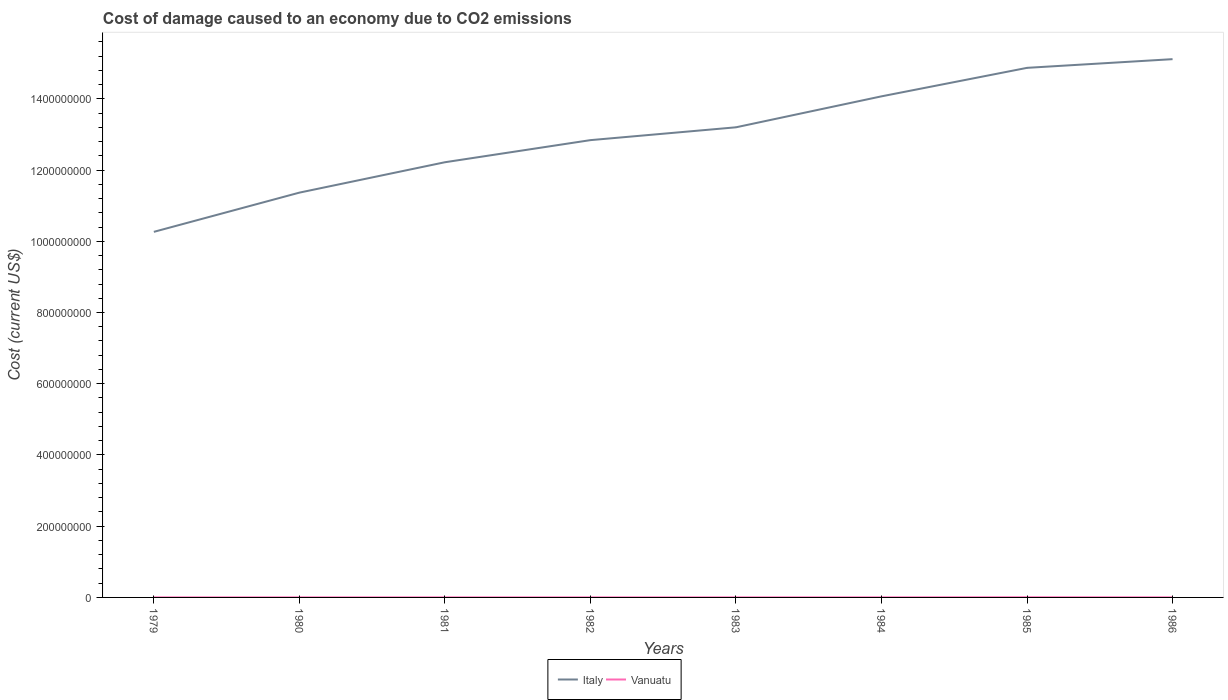Does the line corresponding to Italy intersect with the line corresponding to Vanuatu?
Provide a succinct answer. No. Is the number of lines equal to the number of legend labels?
Ensure brevity in your answer.  Yes. Across all years, what is the maximum cost of damage caused due to CO2 emissisons in Vanuatu?
Ensure brevity in your answer.  1.65e+05. In which year was the cost of damage caused due to CO2 emissisons in Italy maximum?
Your answer should be compact. 1979. What is the total cost of damage caused due to CO2 emissisons in Italy in the graph?
Keep it short and to the point. -3.60e+07. What is the difference between the highest and the second highest cost of damage caused due to CO2 emissisons in Vanuatu?
Make the answer very short. 3.18e+05. What is the difference between the highest and the lowest cost of damage caused due to CO2 emissisons in Vanuatu?
Offer a very short reply. 2. How many years are there in the graph?
Ensure brevity in your answer.  8. Where does the legend appear in the graph?
Offer a very short reply. Bottom center. How are the legend labels stacked?
Give a very brief answer. Horizontal. What is the title of the graph?
Your answer should be compact. Cost of damage caused to an economy due to CO2 emissions. What is the label or title of the X-axis?
Your response must be concise. Years. What is the label or title of the Y-axis?
Offer a very short reply. Cost (current US$). What is the Cost (current US$) in Italy in 1979?
Give a very brief answer. 1.03e+09. What is the Cost (current US$) of Vanuatu in 1979?
Your response must be concise. 1.65e+05. What is the Cost (current US$) in Italy in 1980?
Provide a short and direct response. 1.14e+09. What is the Cost (current US$) in Vanuatu in 1980?
Your answer should be compact. 1.82e+05. What is the Cost (current US$) in Italy in 1981?
Your answer should be compact. 1.22e+09. What is the Cost (current US$) of Vanuatu in 1981?
Keep it short and to the point. 1.66e+05. What is the Cost (current US$) of Italy in 1982?
Provide a short and direct response. 1.28e+09. What is the Cost (current US$) in Vanuatu in 1982?
Give a very brief answer. 1.78e+05. What is the Cost (current US$) of Italy in 1983?
Ensure brevity in your answer.  1.32e+09. What is the Cost (current US$) in Vanuatu in 1983?
Your response must be concise. 2.01e+05. What is the Cost (current US$) in Italy in 1984?
Give a very brief answer. 1.41e+09. What is the Cost (current US$) of Vanuatu in 1984?
Your answer should be very brief. 2.10e+05. What is the Cost (current US$) in Italy in 1985?
Your response must be concise. 1.49e+09. What is the Cost (current US$) of Vanuatu in 1985?
Provide a succinct answer. 4.84e+05. What is the Cost (current US$) in Italy in 1986?
Make the answer very short. 1.51e+09. What is the Cost (current US$) in Vanuatu in 1986?
Provide a succinct answer. 2.42e+05. Across all years, what is the maximum Cost (current US$) of Italy?
Your answer should be very brief. 1.51e+09. Across all years, what is the maximum Cost (current US$) in Vanuatu?
Give a very brief answer. 4.84e+05. Across all years, what is the minimum Cost (current US$) in Italy?
Make the answer very short. 1.03e+09. Across all years, what is the minimum Cost (current US$) in Vanuatu?
Offer a terse response. 1.65e+05. What is the total Cost (current US$) of Italy in the graph?
Keep it short and to the point. 1.04e+1. What is the total Cost (current US$) in Vanuatu in the graph?
Your answer should be compact. 1.83e+06. What is the difference between the Cost (current US$) of Italy in 1979 and that in 1980?
Provide a succinct answer. -1.10e+08. What is the difference between the Cost (current US$) in Vanuatu in 1979 and that in 1980?
Give a very brief answer. -1.70e+04. What is the difference between the Cost (current US$) of Italy in 1979 and that in 1981?
Offer a very short reply. -1.95e+08. What is the difference between the Cost (current US$) in Vanuatu in 1979 and that in 1981?
Ensure brevity in your answer.  -796.84. What is the difference between the Cost (current US$) of Italy in 1979 and that in 1982?
Keep it short and to the point. -2.58e+08. What is the difference between the Cost (current US$) in Vanuatu in 1979 and that in 1982?
Give a very brief answer. -1.32e+04. What is the difference between the Cost (current US$) in Italy in 1979 and that in 1983?
Keep it short and to the point. -2.94e+08. What is the difference between the Cost (current US$) of Vanuatu in 1979 and that in 1983?
Your answer should be compact. -3.58e+04. What is the difference between the Cost (current US$) of Italy in 1979 and that in 1984?
Ensure brevity in your answer.  -3.80e+08. What is the difference between the Cost (current US$) of Vanuatu in 1979 and that in 1984?
Make the answer very short. -4.53e+04. What is the difference between the Cost (current US$) of Italy in 1979 and that in 1985?
Your answer should be very brief. -4.60e+08. What is the difference between the Cost (current US$) in Vanuatu in 1979 and that in 1985?
Provide a succinct answer. -3.18e+05. What is the difference between the Cost (current US$) in Italy in 1979 and that in 1986?
Provide a succinct answer. -4.85e+08. What is the difference between the Cost (current US$) in Vanuatu in 1979 and that in 1986?
Provide a short and direct response. -7.68e+04. What is the difference between the Cost (current US$) in Italy in 1980 and that in 1981?
Provide a short and direct response. -8.53e+07. What is the difference between the Cost (current US$) in Vanuatu in 1980 and that in 1981?
Offer a terse response. 1.62e+04. What is the difference between the Cost (current US$) of Italy in 1980 and that in 1982?
Your response must be concise. -1.47e+08. What is the difference between the Cost (current US$) in Vanuatu in 1980 and that in 1982?
Ensure brevity in your answer.  3847.55. What is the difference between the Cost (current US$) of Italy in 1980 and that in 1983?
Your response must be concise. -1.83e+08. What is the difference between the Cost (current US$) of Vanuatu in 1980 and that in 1983?
Ensure brevity in your answer.  -1.88e+04. What is the difference between the Cost (current US$) in Italy in 1980 and that in 1984?
Provide a succinct answer. -2.70e+08. What is the difference between the Cost (current US$) of Vanuatu in 1980 and that in 1984?
Ensure brevity in your answer.  -2.83e+04. What is the difference between the Cost (current US$) in Italy in 1980 and that in 1985?
Provide a succinct answer. -3.50e+08. What is the difference between the Cost (current US$) in Vanuatu in 1980 and that in 1985?
Make the answer very short. -3.01e+05. What is the difference between the Cost (current US$) of Italy in 1980 and that in 1986?
Give a very brief answer. -3.75e+08. What is the difference between the Cost (current US$) of Vanuatu in 1980 and that in 1986?
Your answer should be compact. -5.98e+04. What is the difference between the Cost (current US$) of Italy in 1981 and that in 1982?
Give a very brief answer. -6.21e+07. What is the difference between the Cost (current US$) in Vanuatu in 1981 and that in 1982?
Make the answer very short. -1.24e+04. What is the difference between the Cost (current US$) in Italy in 1981 and that in 1983?
Offer a very short reply. -9.81e+07. What is the difference between the Cost (current US$) in Vanuatu in 1981 and that in 1983?
Your answer should be very brief. -3.50e+04. What is the difference between the Cost (current US$) in Italy in 1981 and that in 1984?
Keep it short and to the point. -1.85e+08. What is the difference between the Cost (current US$) of Vanuatu in 1981 and that in 1984?
Keep it short and to the point. -4.46e+04. What is the difference between the Cost (current US$) in Italy in 1981 and that in 1985?
Ensure brevity in your answer.  -2.65e+08. What is the difference between the Cost (current US$) in Vanuatu in 1981 and that in 1985?
Give a very brief answer. -3.18e+05. What is the difference between the Cost (current US$) of Italy in 1981 and that in 1986?
Offer a very short reply. -2.89e+08. What is the difference between the Cost (current US$) in Vanuatu in 1981 and that in 1986?
Offer a very short reply. -7.60e+04. What is the difference between the Cost (current US$) in Italy in 1982 and that in 1983?
Make the answer very short. -3.60e+07. What is the difference between the Cost (current US$) of Vanuatu in 1982 and that in 1983?
Offer a very short reply. -2.26e+04. What is the difference between the Cost (current US$) in Italy in 1982 and that in 1984?
Keep it short and to the point. -1.23e+08. What is the difference between the Cost (current US$) in Vanuatu in 1982 and that in 1984?
Offer a very short reply. -3.22e+04. What is the difference between the Cost (current US$) in Italy in 1982 and that in 1985?
Your response must be concise. -2.03e+08. What is the difference between the Cost (current US$) of Vanuatu in 1982 and that in 1985?
Give a very brief answer. -3.05e+05. What is the difference between the Cost (current US$) in Italy in 1982 and that in 1986?
Your response must be concise. -2.27e+08. What is the difference between the Cost (current US$) in Vanuatu in 1982 and that in 1986?
Your response must be concise. -6.37e+04. What is the difference between the Cost (current US$) in Italy in 1983 and that in 1984?
Offer a terse response. -8.69e+07. What is the difference between the Cost (current US$) in Vanuatu in 1983 and that in 1984?
Your answer should be compact. -9573.04. What is the difference between the Cost (current US$) of Italy in 1983 and that in 1985?
Offer a terse response. -1.67e+08. What is the difference between the Cost (current US$) in Vanuatu in 1983 and that in 1985?
Offer a very short reply. -2.83e+05. What is the difference between the Cost (current US$) in Italy in 1983 and that in 1986?
Your answer should be very brief. -1.91e+08. What is the difference between the Cost (current US$) in Vanuatu in 1983 and that in 1986?
Offer a terse response. -4.11e+04. What is the difference between the Cost (current US$) of Italy in 1984 and that in 1985?
Your response must be concise. -8.00e+07. What is the difference between the Cost (current US$) in Vanuatu in 1984 and that in 1985?
Make the answer very short. -2.73e+05. What is the difference between the Cost (current US$) in Italy in 1984 and that in 1986?
Ensure brevity in your answer.  -1.04e+08. What is the difference between the Cost (current US$) in Vanuatu in 1984 and that in 1986?
Keep it short and to the point. -3.15e+04. What is the difference between the Cost (current US$) in Italy in 1985 and that in 1986?
Give a very brief answer. -2.44e+07. What is the difference between the Cost (current US$) of Vanuatu in 1985 and that in 1986?
Offer a very short reply. 2.42e+05. What is the difference between the Cost (current US$) in Italy in 1979 and the Cost (current US$) in Vanuatu in 1980?
Give a very brief answer. 1.03e+09. What is the difference between the Cost (current US$) of Italy in 1979 and the Cost (current US$) of Vanuatu in 1981?
Your answer should be very brief. 1.03e+09. What is the difference between the Cost (current US$) in Italy in 1979 and the Cost (current US$) in Vanuatu in 1982?
Make the answer very short. 1.03e+09. What is the difference between the Cost (current US$) of Italy in 1979 and the Cost (current US$) of Vanuatu in 1983?
Provide a short and direct response. 1.03e+09. What is the difference between the Cost (current US$) in Italy in 1979 and the Cost (current US$) in Vanuatu in 1984?
Keep it short and to the point. 1.03e+09. What is the difference between the Cost (current US$) in Italy in 1979 and the Cost (current US$) in Vanuatu in 1985?
Make the answer very short. 1.03e+09. What is the difference between the Cost (current US$) in Italy in 1979 and the Cost (current US$) in Vanuatu in 1986?
Keep it short and to the point. 1.03e+09. What is the difference between the Cost (current US$) in Italy in 1980 and the Cost (current US$) in Vanuatu in 1981?
Ensure brevity in your answer.  1.14e+09. What is the difference between the Cost (current US$) of Italy in 1980 and the Cost (current US$) of Vanuatu in 1982?
Offer a very short reply. 1.14e+09. What is the difference between the Cost (current US$) of Italy in 1980 and the Cost (current US$) of Vanuatu in 1983?
Provide a short and direct response. 1.14e+09. What is the difference between the Cost (current US$) in Italy in 1980 and the Cost (current US$) in Vanuatu in 1984?
Provide a short and direct response. 1.14e+09. What is the difference between the Cost (current US$) in Italy in 1980 and the Cost (current US$) in Vanuatu in 1985?
Offer a very short reply. 1.14e+09. What is the difference between the Cost (current US$) of Italy in 1980 and the Cost (current US$) of Vanuatu in 1986?
Offer a terse response. 1.14e+09. What is the difference between the Cost (current US$) in Italy in 1981 and the Cost (current US$) in Vanuatu in 1982?
Offer a terse response. 1.22e+09. What is the difference between the Cost (current US$) in Italy in 1981 and the Cost (current US$) in Vanuatu in 1983?
Your response must be concise. 1.22e+09. What is the difference between the Cost (current US$) of Italy in 1981 and the Cost (current US$) of Vanuatu in 1984?
Offer a terse response. 1.22e+09. What is the difference between the Cost (current US$) in Italy in 1981 and the Cost (current US$) in Vanuatu in 1985?
Provide a short and direct response. 1.22e+09. What is the difference between the Cost (current US$) in Italy in 1981 and the Cost (current US$) in Vanuatu in 1986?
Provide a succinct answer. 1.22e+09. What is the difference between the Cost (current US$) in Italy in 1982 and the Cost (current US$) in Vanuatu in 1983?
Make the answer very short. 1.28e+09. What is the difference between the Cost (current US$) of Italy in 1982 and the Cost (current US$) of Vanuatu in 1984?
Provide a succinct answer. 1.28e+09. What is the difference between the Cost (current US$) in Italy in 1982 and the Cost (current US$) in Vanuatu in 1985?
Offer a very short reply. 1.28e+09. What is the difference between the Cost (current US$) of Italy in 1982 and the Cost (current US$) of Vanuatu in 1986?
Keep it short and to the point. 1.28e+09. What is the difference between the Cost (current US$) in Italy in 1983 and the Cost (current US$) in Vanuatu in 1984?
Provide a succinct answer. 1.32e+09. What is the difference between the Cost (current US$) of Italy in 1983 and the Cost (current US$) of Vanuatu in 1985?
Your answer should be compact. 1.32e+09. What is the difference between the Cost (current US$) in Italy in 1983 and the Cost (current US$) in Vanuatu in 1986?
Ensure brevity in your answer.  1.32e+09. What is the difference between the Cost (current US$) of Italy in 1984 and the Cost (current US$) of Vanuatu in 1985?
Your response must be concise. 1.41e+09. What is the difference between the Cost (current US$) in Italy in 1984 and the Cost (current US$) in Vanuatu in 1986?
Offer a terse response. 1.41e+09. What is the difference between the Cost (current US$) in Italy in 1985 and the Cost (current US$) in Vanuatu in 1986?
Offer a terse response. 1.49e+09. What is the average Cost (current US$) in Italy per year?
Provide a succinct answer. 1.30e+09. What is the average Cost (current US$) in Vanuatu per year?
Your response must be concise. 2.29e+05. In the year 1979, what is the difference between the Cost (current US$) of Italy and Cost (current US$) of Vanuatu?
Offer a very short reply. 1.03e+09. In the year 1980, what is the difference between the Cost (current US$) in Italy and Cost (current US$) in Vanuatu?
Ensure brevity in your answer.  1.14e+09. In the year 1981, what is the difference between the Cost (current US$) of Italy and Cost (current US$) of Vanuatu?
Provide a short and direct response. 1.22e+09. In the year 1982, what is the difference between the Cost (current US$) of Italy and Cost (current US$) of Vanuatu?
Provide a short and direct response. 1.28e+09. In the year 1983, what is the difference between the Cost (current US$) in Italy and Cost (current US$) in Vanuatu?
Provide a short and direct response. 1.32e+09. In the year 1984, what is the difference between the Cost (current US$) of Italy and Cost (current US$) of Vanuatu?
Keep it short and to the point. 1.41e+09. In the year 1985, what is the difference between the Cost (current US$) of Italy and Cost (current US$) of Vanuatu?
Make the answer very short. 1.49e+09. In the year 1986, what is the difference between the Cost (current US$) in Italy and Cost (current US$) in Vanuatu?
Offer a terse response. 1.51e+09. What is the ratio of the Cost (current US$) in Italy in 1979 to that in 1980?
Your answer should be compact. 0.9. What is the ratio of the Cost (current US$) of Vanuatu in 1979 to that in 1980?
Your response must be concise. 0.91. What is the ratio of the Cost (current US$) in Italy in 1979 to that in 1981?
Ensure brevity in your answer.  0.84. What is the ratio of the Cost (current US$) of Vanuatu in 1979 to that in 1981?
Keep it short and to the point. 1. What is the ratio of the Cost (current US$) in Italy in 1979 to that in 1982?
Your answer should be very brief. 0.8. What is the ratio of the Cost (current US$) in Vanuatu in 1979 to that in 1982?
Provide a succinct answer. 0.93. What is the ratio of the Cost (current US$) of Italy in 1979 to that in 1983?
Your answer should be very brief. 0.78. What is the ratio of the Cost (current US$) in Vanuatu in 1979 to that in 1983?
Make the answer very short. 0.82. What is the ratio of the Cost (current US$) of Italy in 1979 to that in 1984?
Your answer should be very brief. 0.73. What is the ratio of the Cost (current US$) of Vanuatu in 1979 to that in 1984?
Your answer should be compact. 0.78. What is the ratio of the Cost (current US$) of Italy in 1979 to that in 1985?
Offer a very short reply. 0.69. What is the ratio of the Cost (current US$) in Vanuatu in 1979 to that in 1985?
Give a very brief answer. 0.34. What is the ratio of the Cost (current US$) in Italy in 1979 to that in 1986?
Offer a very short reply. 0.68. What is the ratio of the Cost (current US$) in Vanuatu in 1979 to that in 1986?
Make the answer very short. 0.68. What is the ratio of the Cost (current US$) of Italy in 1980 to that in 1981?
Keep it short and to the point. 0.93. What is the ratio of the Cost (current US$) of Vanuatu in 1980 to that in 1981?
Provide a succinct answer. 1.1. What is the ratio of the Cost (current US$) of Italy in 1980 to that in 1982?
Make the answer very short. 0.89. What is the ratio of the Cost (current US$) in Vanuatu in 1980 to that in 1982?
Provide a succinct answer. 1.02. What is the ratio of the Cost (current US$) of Italy in 1980 to that in 1983?
Make the answer very short. 0.86. What is the ratio of the Cost (current US$) of Vanuatu in 1980 to that in 1983?
Offer a very short reply. 0.91. What is the ratio of the Cost (current US$) in Italy in 1980 to that in 1984?
Provide a succinct answer. 0.81. What is the ratio of the Cost (current US$) in Vanuatu in 1980 to that in 1984?
Make the answer very short. 0.87. What is the ratio of the Cost (current US$) of Italy in 1980 to that in 1985?
Make the answer very short. 0.76. What is the ratio of the Cost (current US$) of Vanuatu in 1980 to that in 1985?
Provide a short and direct response. 0.38. What is the ratio of the Cost (current US$) in Italy in 1980 to that in 1986?
Keep it short and to the point. 0.75. What is the ratio of the Cost (current US$) in Vanuatu in 1980 to that in 1986?
Ensure brevity in your answer.  0.75. What is the ratio of the Cost (current US$) of Italy in 1981 to that in 1982?
Make the answer very short. 0.95. What is the ratio of the Cost (current US$) in Vanuatu in 1981 to that in 1982?
Offer a terse response. 0.93. What is the ratio of the Cost (current US$) of Italy in 1981 to that in 1983?
Offer a terse response. 0.93. What is the ratio of the Cost (current US$) of Vanuatu in 1981 to that in 1983?
Provide a short and direct response. 0.83. What is the ratio of the Cost (current US$) in Italy in 1981 to that in 1984?
Ensure brevity in your answer.  0.87. What is the ratio of the Cost (current US$) of Vanuatu in 1981 to that in 1984?
Your answer should be very brief. 0.79. What is the ratio of the Cost (current US$) in Italy in 1981 to that in 1985?
Keep it short and to the point. 0.82. What is the ratio of the Cost (current US$) of Vanuatu in 1981 to that in 1985?
Provide a short and direct response. 0.34. What is the ratio of the Cost (current US$) of Italy in 1981 to that in 1986?
Make the answer very short. 0.81. What is the ratio of the Cost (current US$) in Vanuatu in 1981 to that in 1986?
Your response must be concise. 0.69. What is the ratio of the Cost (current US$) in Italy in 1982 to that in 1983?
Offer a terse response. 0.97. What is the ratio of the Cost (current US$) of Vanuatu in 1982 to that in 1983?
Give a very brief answer. 0.89. What is the ratio of the Cost (current US$) in Italy in 1982 to that in 1984?
Provide a succinct answer. 0.91. What is the ratio of the Cost (current US$) in Vanuatu in 1982 to that in 1984?
Ensure brevity in your answer.  0.85. What is the ratio of the Cost (current US$) in Italy in 1982 to that in 1985?
Give a very brief answer. 0.86. What is the ratio of the Cost (current US$) in Vanuatu in 1982 to that in 1985?
Your answer should be compact. 0.37. What is the ratio of the Cost (current US$) of Italy in 1982 to that in 1986?
Offer a very short reply. 0.85. What is the ratio of the Cost (current US$) of Vanuatu in 1982 to that in 1986?
Provide a succinct answer. 0.74. What is the ratio of the Cost (current US$) in Italy in 1983 to that in 1984?
Provide a short and direct response. 0.94. What is the ratio of the Cost (current US$) of Vanuatu in 1983 to that in 1984?
Offer a terse response. 0.95. What is the ratio of the Cost (current US$) in Italy in 1983 to that in 1985?
Provide a succinct answer. 0.89. What is the ratio of the Cost (current US$) in Vanuatu in 1983 to that in 1985?
Your answer should be compact. 0.42. What is the ratio of the Cost (current US$) of Italy in 1983 to that in 1986?
Provide a short and direct response. 0.87. What is the ratio of the Cost (current US$) in Vanuatu in 1983 to that in 1986?
Make the answer very short. 0.83. What is the ratio of the Cost (current US$) of Italy in 1984 to that in 1985?
Provide a succinct answer. 0.95. What is the ratio of the Cost (current US$) in Vanuatu in 1984 to that in 1985?
Offer a very short reply. 0.44. What is the ratio of the Cost (current US$) of Italy in 1984 to that in 1986?
Offer a very short reply. 0.93. What is the ratio of the Cost (current US$) of Vanuatu in 1984 to that in 1986?
Give a very brief answer. 0.87. What is the ratio of the Cost (current US$) in Italy in 1985 to that in 1986?
Your response must be concise. 0.98. What is the ratio of the Cost (current US$) of Vanuatu in 1985 to that in 1986?
Give a very brief answer. 2. What is the difference between the highest and the second highest Cost (current US$) in Italy?
Ensure brevity in your answer.  2.44e+07. What is the difference between the highest and the second highest Cost (current US$) of Vanuatu?
Your answer should be very brief. 2.42e+05. What is the difference between the highest and the lowest Cost (current US$) in Italy?
Your response must be concise. 4.85e+08. What is the difference between the highest and the lowest Cost (current US$) of Vanuatu?
Your answer should be very brief. 3.18e+05. 